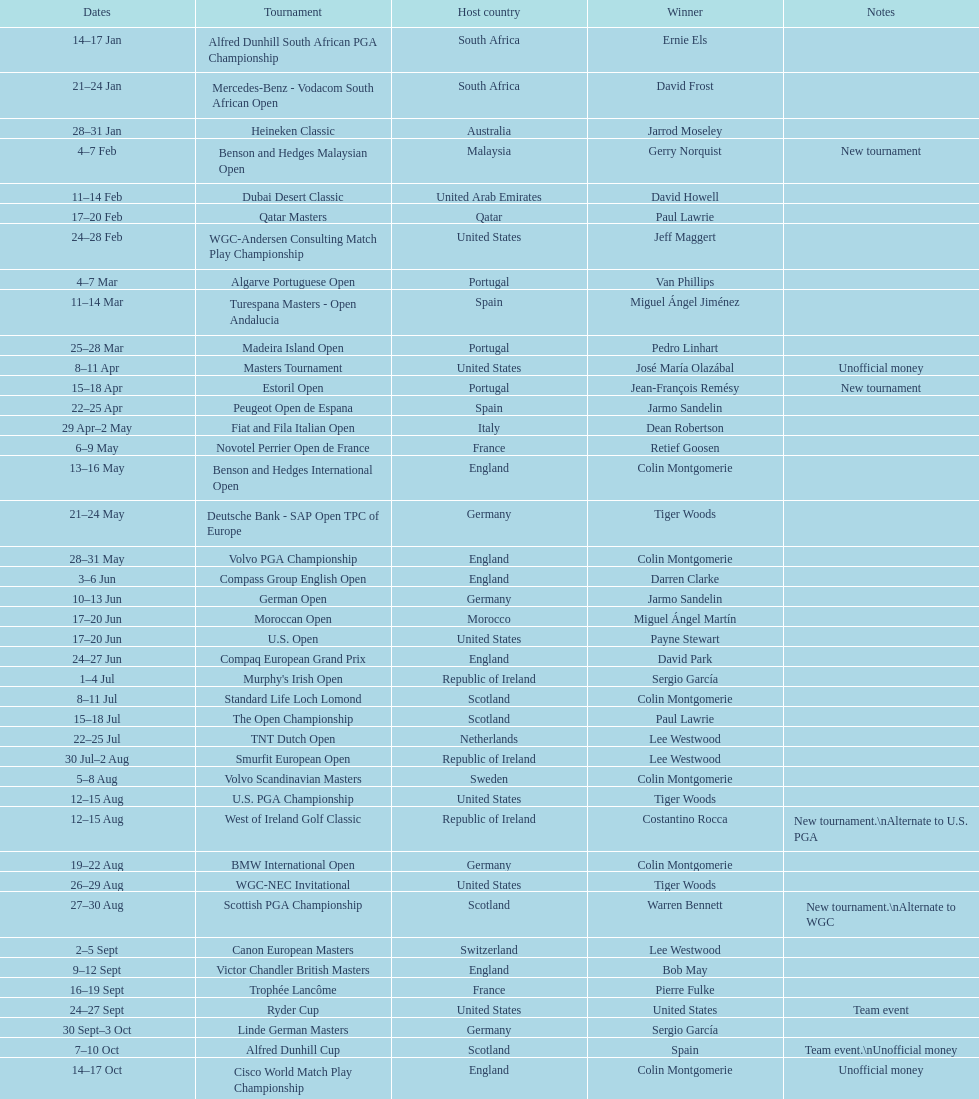How many tournaments began before aug 15th 31. 